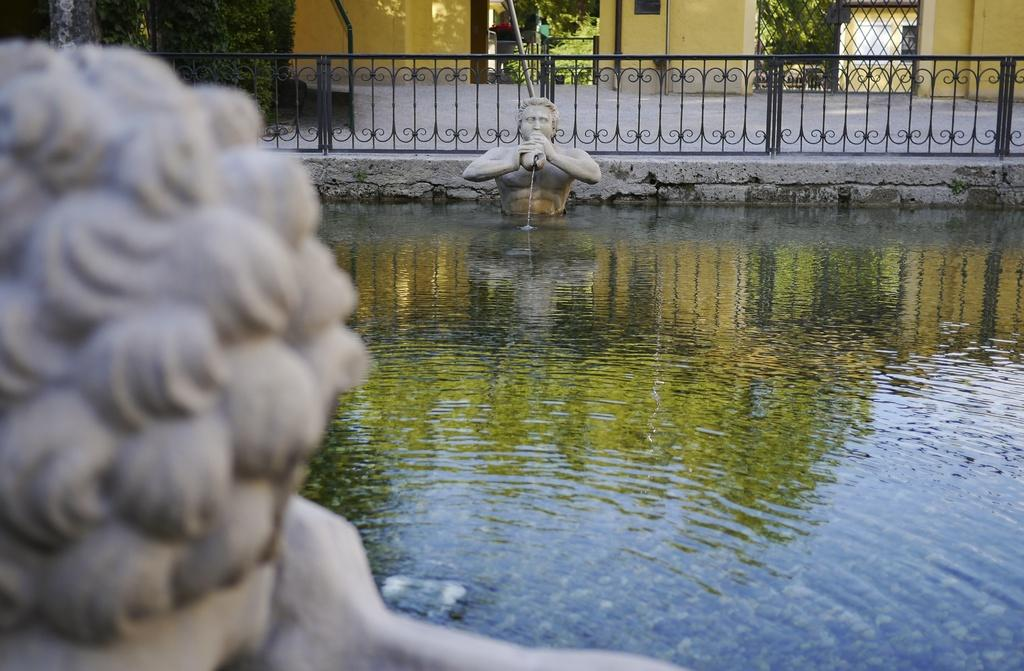What can be seen in the water in the image? There are two statues in the water. What is present from left to right in the image? There is some fencing from left to right in the image. What can be seen in the background of the image? There are trees and buildings visible in the background. How many apples are on the owl's head in the image? There are no apples or owls present in the image. What is the mother doing in the image? There is no mother or any indication of a person's presence in the image. 